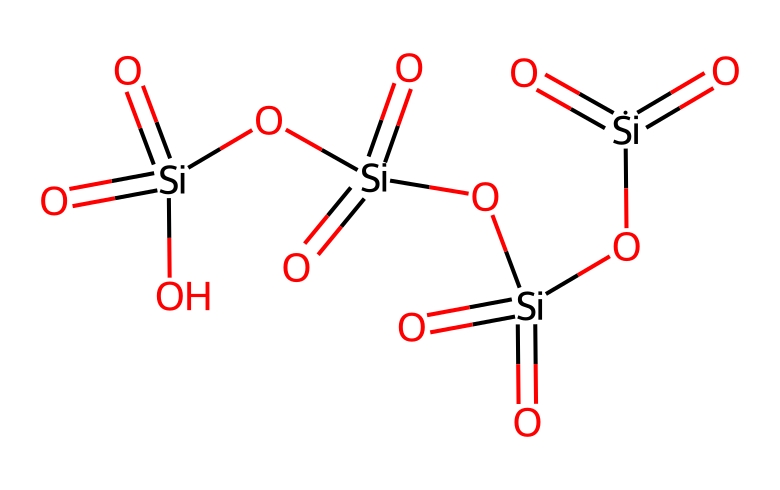how many silicon atoms are in the structure? By examining the SMILES representation, you can count the number of silicon atoms denoted by [Si]. The structure has four occurrences of [Si], indicating four silicon atoms.
Answer: four what type of chemical bonding is predominantly present in this compound? The structure shows silicon atoms double-bonded to oxygen atoms and single-bonded to hydroxyl groups, indicating covalent bonding as the predominant type of bonding in acid anhydrides.
Answer: covalent how many oxygen atoms are there in total? The SMILES represents four silicon atoms each bonded to two oxygen atoms and two more oxygen atoms brought in by hydroxyl groups. Thus, there are eight oxygen atoms in total.
Answer: eight does this chemical contain any functional groups? The presence of -OH groups in the structure indicates that the chemical has hydroxyl functional groups, characteristic of acid anhydrides, which can also be connected through their oxide links.
Answer: hydroxyl what is the molecular formula based on the given structure? By identifying the types and counts of atoms in the SMILES representation, we can derive the molecular formula as Si4O8, accounting for four silicon atoms and eight oxygen atoms.
Answer: Si4O8 what is the chemical classification of this compound? The SMILES structure indicates the presence of multiple silicon atoms in an anhydrous arrangement connected with oxygen atoms, defining it as an acid anhydride, specifically of silicic acid upon hydration.
Answer: acid anhydride how many total double bonds are present in this structure? Looking at the SMILES, each silicon atom is double-bonded to each oxygen atom twice. Since there are four silicon atoms, this results in a total of four double bonds in the structure.
Answer: four 